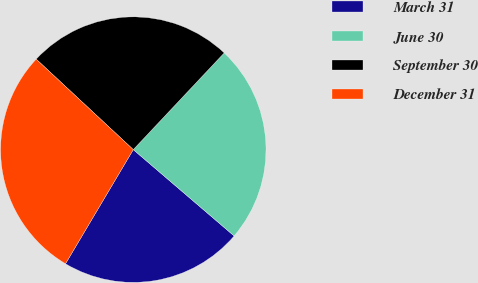Convert chart. <chart><loc_0><loc_0><loc_500><loc_500><pie_chart><fcel>March 31<fcel>June 30<fcel>September 30<fcel>December 31<nl><fcel>22.26%<fcel>24.26%<fcel>25.07%<fcel>28.41%<nl></chart> 